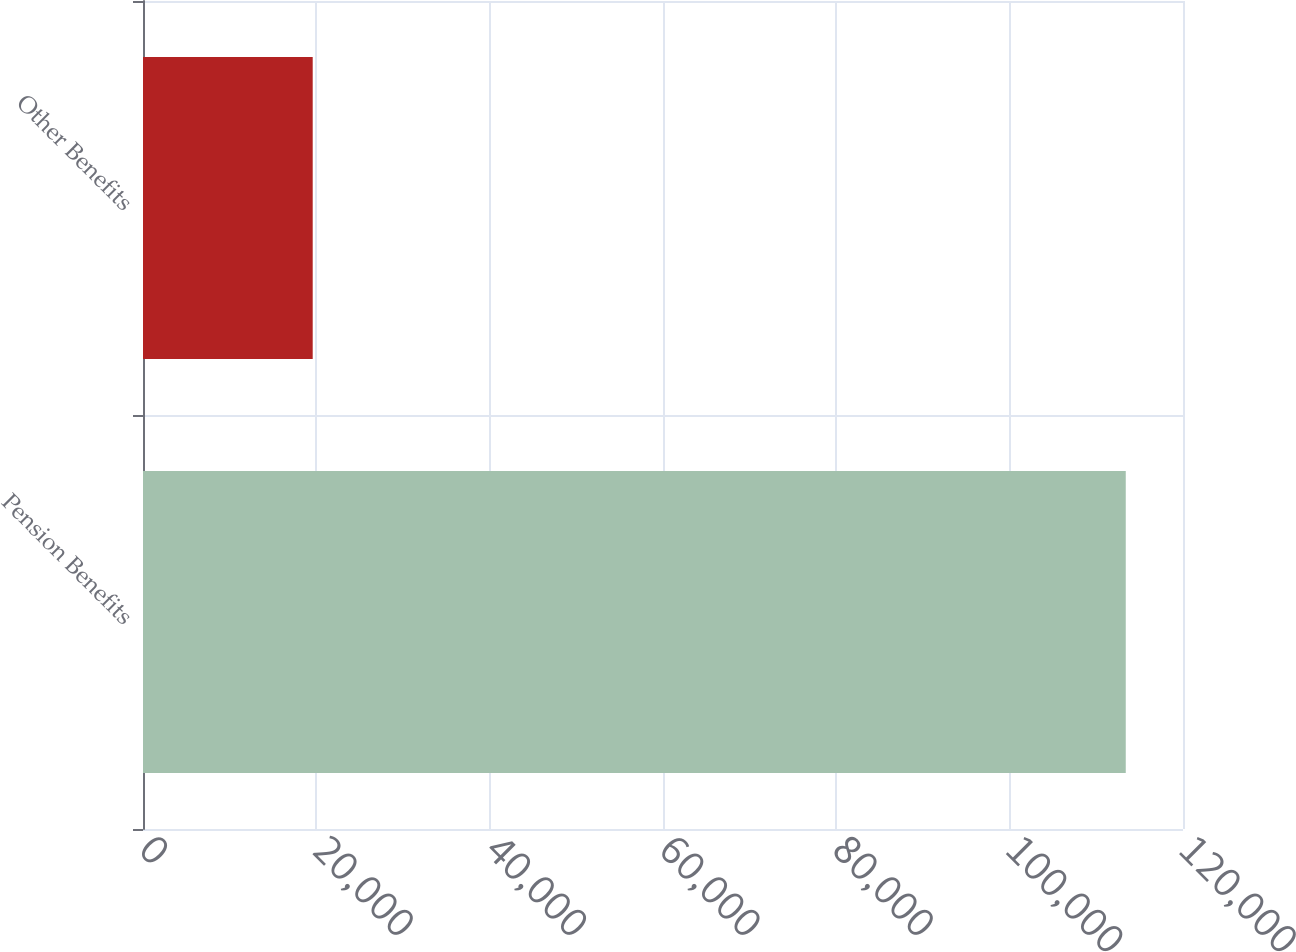Convert chart. <chart><loc_0><loc_0><loc_500><loc_500><bar_chart><fcel>Pension Benefits<fcel>Other Benefits<nl><fcel>113395<fcel>19582<nl></chart> 